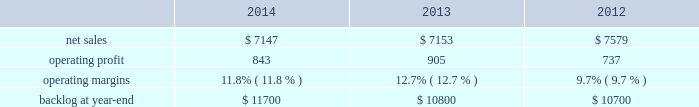Mission systems and training our mst business segment provides ship and submarine mission and combat systems ; mission systems and sensors for rotary and fixed-wing aircraft ; sea and land-based missile defense systems ; radar systems ; littoral combat ships ; simulation and training services ; and unmanned systems and technologies .
Mst 2019s major programs include aegis combat system ( aegis ) , littoral combat ship ( lcs ) , mh-60 , tpq-53 radar system and mk-41 vertical launching system .
Mst 2019s operating results included the following ( in millions ) : .
2014 compared to 2013 mst 2019s net sales for 2014 were comparable to 2013 .
Net sales decreased by approximately $ 85 million for undersea systems programs due to decreased volume and deliveries ; and about $ 55 million related to the settlements of contract cost matters on certain programs ( including a portion of the terminated presidential helicopter program ) in 2013 that were not repeated in 2014 .
The decreases were offset by higher net sales of approximately $ 80 million for integrated warfare systems and sensors programs due to increased volume ( primarily space fence ) ; and approximately $ 40 million for training and logistics solutions programs due to increased deliveries ( primarily close combat tactical trainer ) .
Mst 2019s operating profit for 2014 decreased $ 62 million , or 7% ( 7 % ) , compared to 2013 .
The decrease was primarily attributable to lower operating profit of approximately $ 120 million related to the settlements of contract cost matters on certain programs ( including a portion of the terminated presidential helicopter program ) in 2013 that were not repeated in 2014 ; and approximately $ 45 million due to higher reserves recorded on certain training and logistics solutions programs .
The decreases were partially offset by higher operating profit of approximately $ 45 million for performance matters and reserves recorded in 2013 that were not repeated in 2014 ; and about $ 60 million for various programs due to increased risk retirements ( including mh-60 and radar surveillance programs ) .
Adjustments not related to volume , including net profit booking rate adjustments and other matters , were approximately $ 50 million lower for 2014 compared to 2013 .
2013 compared to 2012 mst 2019s net sales for 2013 decreased $ 426 million , or 6% ( 6 % ) , compared to 2012 .
The decrease was primarily attributable to lower net sales of approximately $ 275 million for various ship and aviation systems programs due to lower volume ( primarily ptds as final surveillance system deliveries occurred during the second quarter of 2012 ) ; about $ 195 million for various integrated warfare systems and sensors programs ( primarily naval systems ) due to lower volume ; approximately $ 65 million for various training and logistics programs due to lower volume ; and about $ 55 million for the aegis program due to lower volume .
The decreases were partially offset by higher net sales of about $ 155 million for the lcs program due to increased volume .
Mst 2019s operating profit for 2013 increased $ 168 million , or 23% ( 23 % ) , compared to 2012 .
The increase was primarily attributable to higher operating profit of approximately $ 120 million related to the settlement of contract cost matters on certain programs ( including a portion of the terminated presidential helicopter program ) ; about $ 55 million for integrated warfare systems and sensors programs ( primarily radar and halifax class modernization programs ) due to increased risk retirements ; and approximately $ 30 million for undersea systems programs due to increased risk retirements .
The increases were partially offset by lower operating profit of about $ 55 million for training and logistics programs , primarily due to the recording of approximately $ 30 million of charges mostly related to lower-of-cost-or-market considerations ; and about $ 25 million for ship and aviation systems programs ( primarily ptds ) due to lower risk retirements and volume .
Operating profit related to the lcs program was comparable .
Adjustments not related to volume , including net profit booking rate adjustments and other matters , were approximately $ 170 million higher for 2013 compared to 2012 .
Backlog backlog increased in 2014 compared to 2013 primarily due to higher orders on new program starts ( such as space fence ) .
Backlog increased slightly in 2013 compared to 2012 mainly due to higher orders and lower sales on integrated warfare system and sensors programs ( primarily aegis ) and lower sales on various service programs , partially offset by lower orders on ship and aviation systems ( primarily mh-60 ) . .
What is the growth rate in net sales for mst in 2014? 
Computations: ((7147 - 7153) / 7153)
Answer: -0.00084. 